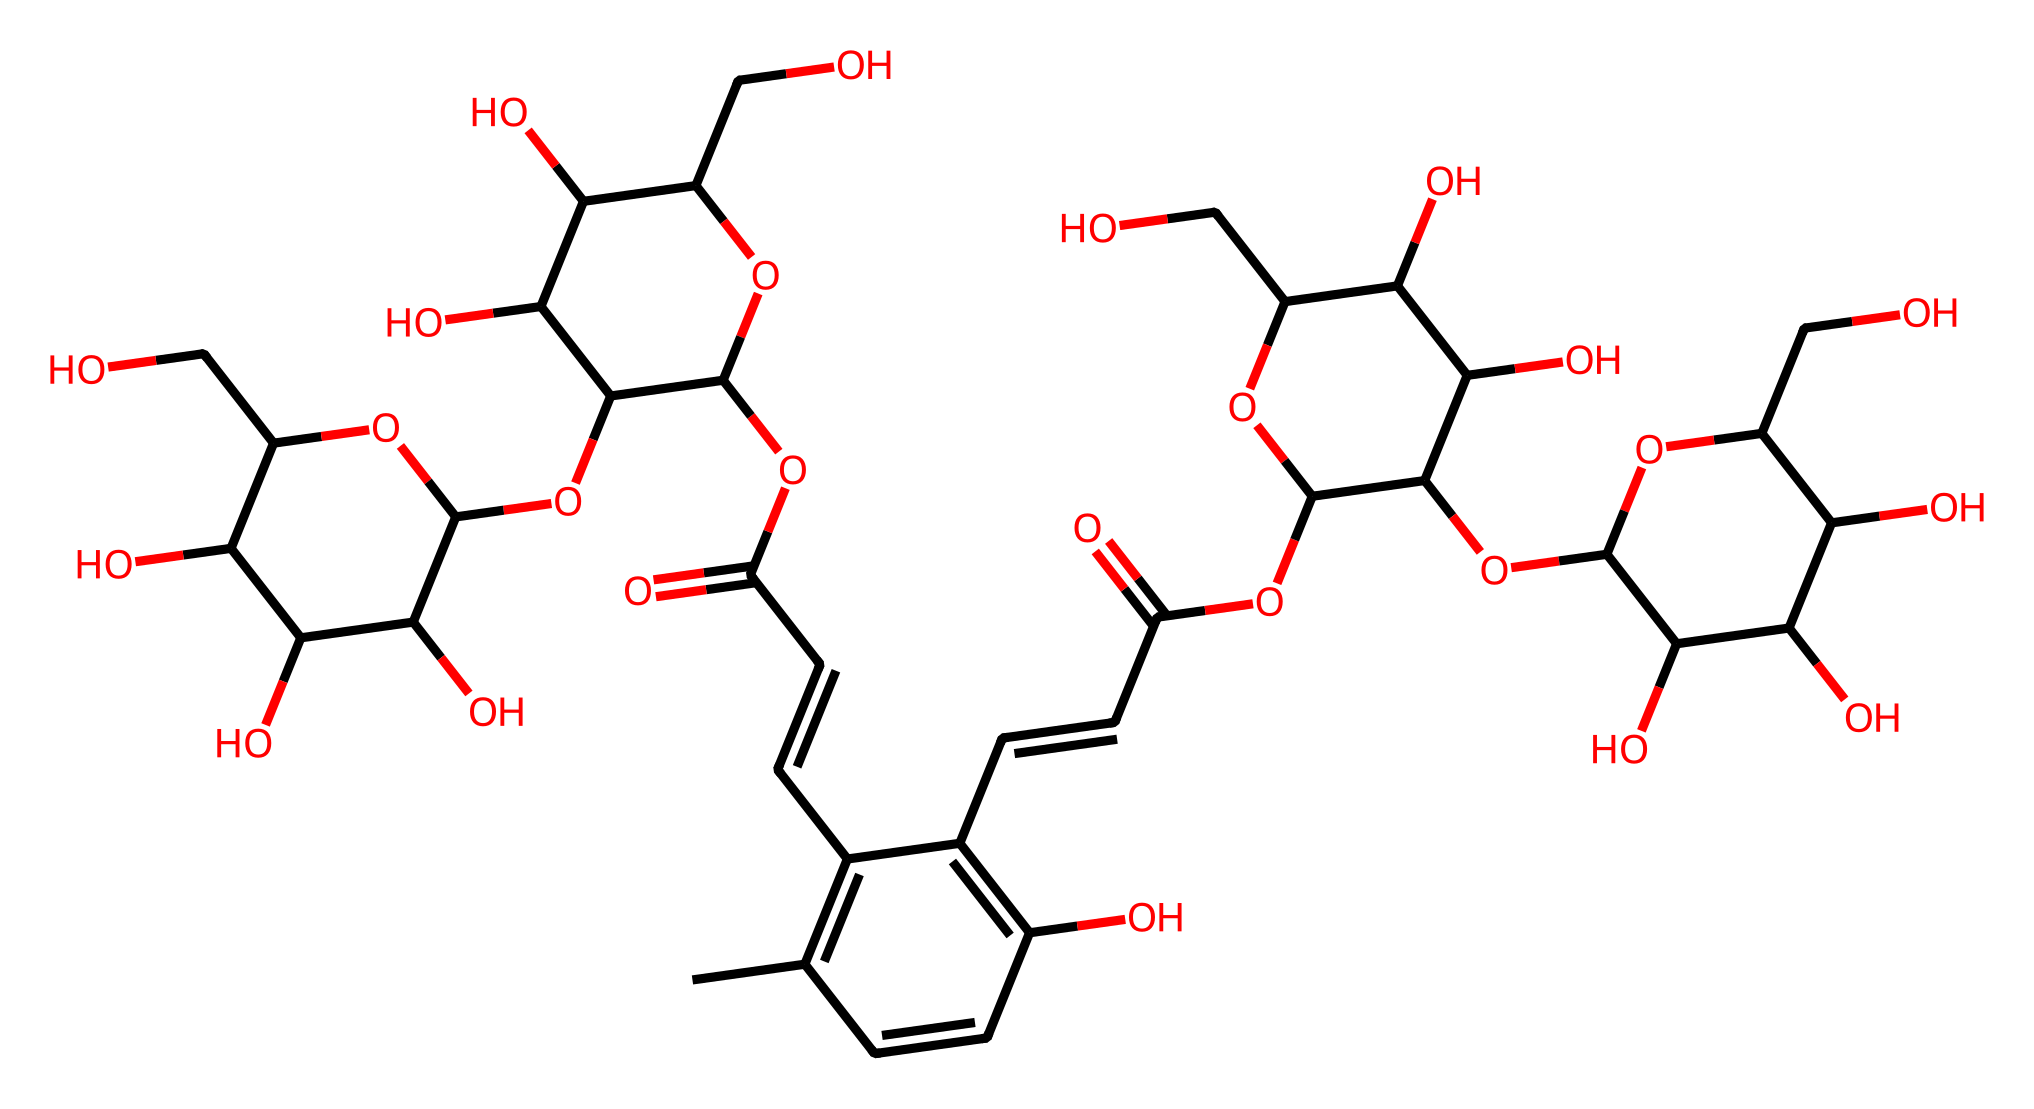What is the total number of carbon atoms in crocin? To count the carbon atoms in a chemical structure, one observes each carbon in the SMILES representation. By analyzing the structure, we identify each instance of 'C' which corresponds to the carbon atoms. For crocin, there are 30 carbon atoms present in the structure.
Answer: 30 How many hydroxyl (OH) groups are present in crocin? Hydroxyl groups can be identified by looking for 'O' in the structure that is directly bound to a 'C' atom, specifically those forming bonds with hydrogen. By examining the SMILES code, we determine that there are 8 hydroxyl (OH) groups in crocin.
Answer: 8 What type of organic compound is crocin classified as? Crocin, based on its structure, can be identified as a glycoside due to the presence of sugar moieties attached to a non-sugar part (aglycone). This classification is confirmed by examining the structure for sugar-like rings and functional groups.
Answer: glycoside What functional groups are clearly identifiable in the crocin structure? The functionality in the structure can be inferred from the presence of certain common patterns such as -OH (alcohol), -O- (ether), and carbonyl (C=O), noted in the structure. Upon careful observation, we see that crocin has both alcohol and ester functional groups. Therefore, we categorize the visible functional groups.
Answer: alcohol and ester What is the approximate molecular weight of crocin? To estimate the molecular weight, the weights of each type of atom (C, H, O) are summed, multiplied by their respective counts identified in the structure. For crocin, the approximate molecular weight calculated from its composition is around 568.5 g/mol.
Answer: 568.5 g/mol What is the significance of the double bonds in the crocin structure? The presence of double bonds indicates unsaturation in the chemical structure. Unsaturation can influence the reactivity and stability of the compound. In crocin, the double bonds contribute to its aromatic character and may affect its properties and interactions.
Answer: contributes to aromatic character What does the presence of multiple sugar units suggest about crocin's solubility? The multiple sugar units in crocin suggest that it is likely more polar and thus has enhanced solubility in water due to hydrogen bonding capabilities. This is because sugars are generally hydrophilic and can interact well with water molecules.
Answer: increased solubility in water 